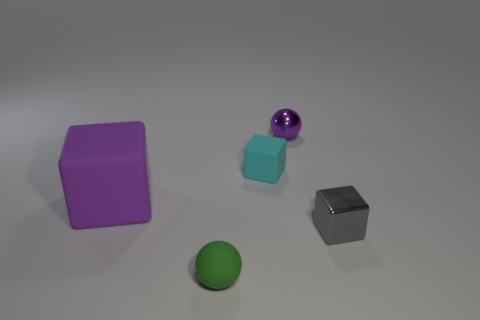What is the material of the large block that is the same color as the tiny shiny ball?
Provide a succinct answer. Rubber. There is a big object that is the same shape as the tiny gray shiny object; what material is it?
Offer a very short reply. Rubber. The thing left of the sphere on the left side of the purple ball is what color?
Provide a succinct answer. Purple. What number of rubber things are small purple things or big purple cylinders?
Offer a terse response. 0. Are the purple sphere and the tiny cyan thing made of the same material?
Ensure brevity in your answer.  No. The ball that is behind the tiny thing in front of the gray metallic thing is made of what material?
Offer a very short reply. Metal. What number of tiny objects are blue rubber balls or spheres?
Your answer should be compact. 2. The green rubber object has what size?
Offer a very short reply. Small. Is the number of small purple things that are in front of the cyan thing greater than the number of small gray shiny blocks?
Your answer should be compact. No. Are there the same number of green objects behind the gray block and purple blocks that are in front of the big purple cube?
Your response must be concise. Yes. 